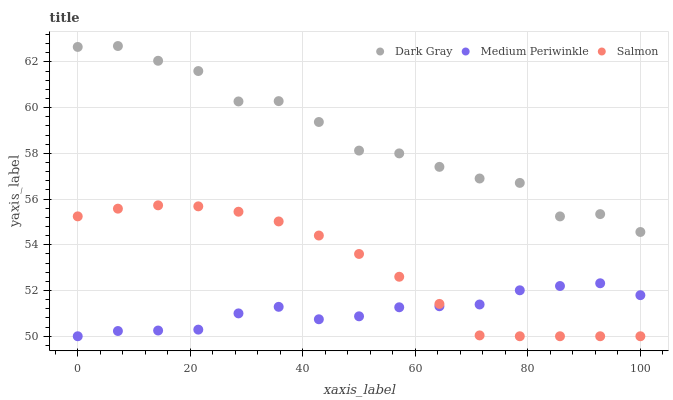Does Medium Periwinkle have the minimum area under the curve?
Answer yes or no. Yes. Does Dark Gray have the maximum area under the curve?
Answer yes or no. Yes. Does Salmon have the minimum area under the curve?
Answer yes or no. No. Does Salmon have the maximum area under the curve?
Answer yes or no. No. Is Salmon the smoothest?
Answer yes or no. Yes. Is Dark Gray the roughest?
Answer yes or no. Yes. Is Medium Periwinkle the smoothest?
Answer yes or no. No. Is Medium Periwinkle the roughest?
Answer yes or no. No. Does Salmon have the lowest value?
Answer yes or no. Yes. Does Dark Gray have the highest value?
Answer yes or no. Yes. Does Salmon have the highest value?
Answer yes or no. No. Is Medium Periwinkle less than Dark Gray?
Answer yes or no. Yes. Is Dark Gray greater than Medium Periwinkle?
Answer yes or no. Yes. Does Medium Periwinkle intersect Salmon?
Answer yes or no. Yes. Is Medium Periwinkle less than Salmon?
Answer yes or no. No. Is Medium Periwinkle greater than Salmon?
Answer yes or no. No. Does Medium Periwinkle intersect Dark Gray?
Answer yes or no. No. 